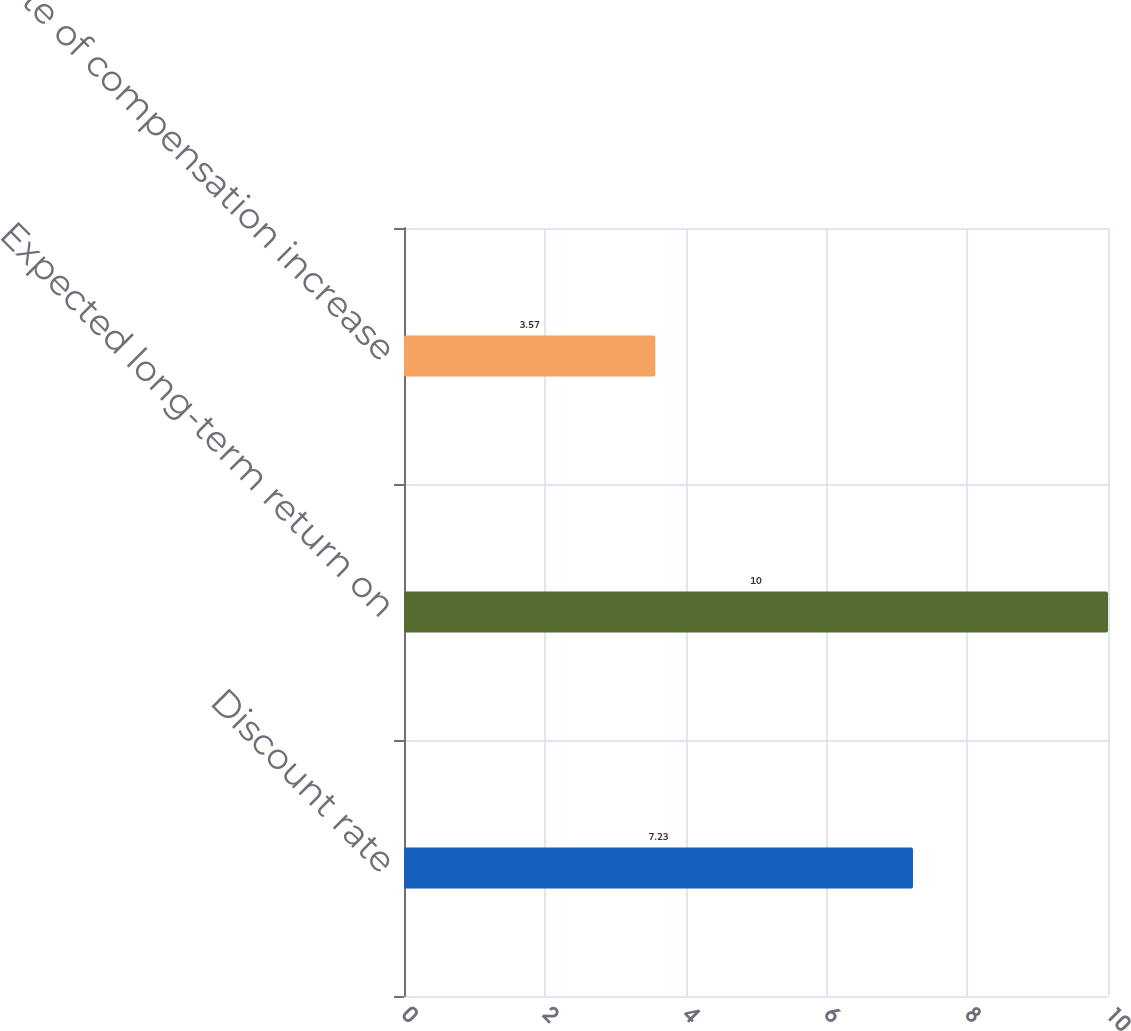Convert chart to OTSL. <chart><loc_0><loc_0><loc_500><loc_500><bar_chart><fcel>Discount rate<fcel>Expected long-term return on<fcel>Rate of compensation increase<nl><fcel>7.23<fcel>10<fcel>3.57<nl></chart> 